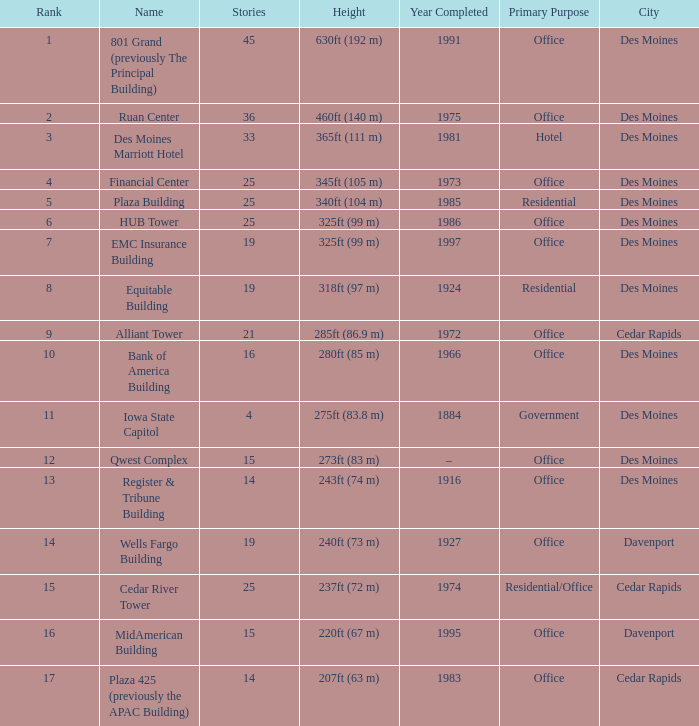What is the elevation of the emc insurance building in des moines? 325ft (99 m). 